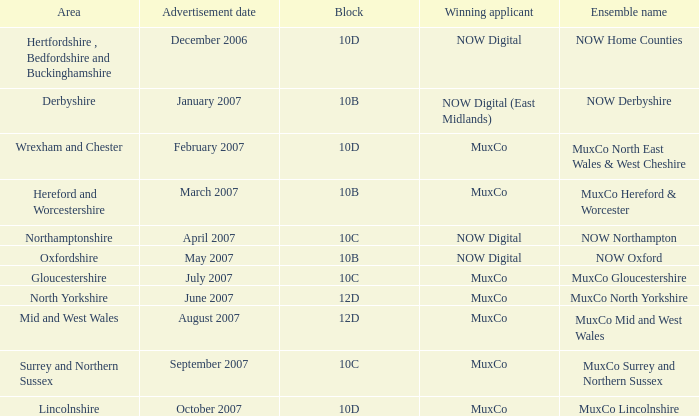Who is the Winning Applicant of Block 10B in Derbyshire Area? NOW Digital (East Midlands). 